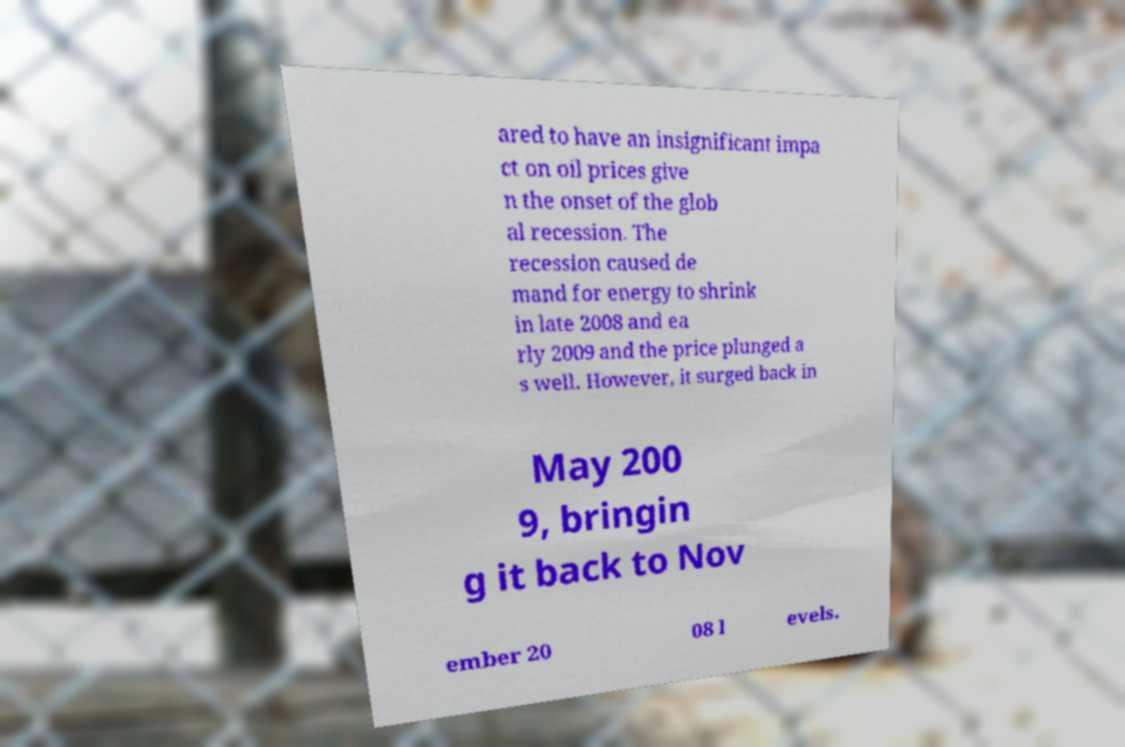Could you assist in decoding the text presented in this image and type it out clearly? ared to have an insignificant impa ct on oil prices give n the onset of the glob al recession. The recession caused de mand for energy to shrink in late 2008 and ea rly 2009 and the price plunged a s well. However, it surged back in May 200 9, bringin g it back to Nov ember 20 08 l evels. 